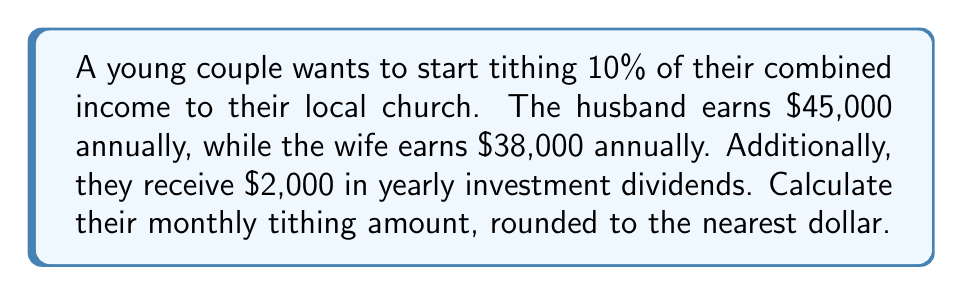Can you solve this math problem? To calculate the monthly tithing amount, we'll follow these steps:

1. Calculate the total annual income:
   $$\text{Total Annual Income} = \text{Husband's Income} + \text{Wife's Income} + \text{Investment Dividends}$$
   $$\text{Total Annual Income} = \$45,000 + \$38,000 + \$2,000 = \$85,000$$

2. Calculate the annual tithing amount (10% of total income):
   $$\text{Annual Tithing} = 10\% \times \text{Total Annual Income}$$
   $$\text{Annual Tithing} = 0.10 \times \$85,000 = \$8,500$$

3. Calculate the monthly tithing amount:
   $$\text{Monthly Tithing} = \frac{\text{Annual Tithing}}{12 \text{ months}}$$
   $$\text{Monthly Tithing} = \frac{\$8,500}{12} = \$708.33$$

4. Round the monthly tithing to the nearest dollar:
   $$\text{Rounded Monthly Tithing} = \text{round}(\$708.33) = \$708$$
Answer: $708 